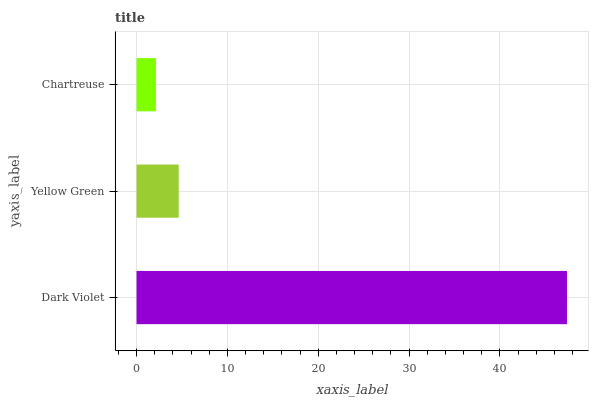Is Chartreuse the minimum?
Answer yes or no. Yes. Is Dark Violet the maximum?
Answer yes or no. Yes. Is Yellow Green the minimum?
Answer yes or no. No. Is Yellow Green the maximum?
Answer yes or no. No. Is Dark Violet greater than Yellow Green?
Answer yes or no. Yes. Is Yellow Green less than Dark Violet?
Answer yes or no. Yes. Is Yellow Green greater than Dark Violet?
Answer yes or no. No. Is Dark Violet less than Yellow Green?
Answer yes or no. No. Is Yellow Green the high median?
Answer yes or no. Yes. Is Yellow Green the low median?
Answer yes or no. Yes. Is Chartreuse the high median?
Answer yes or no. No. Is Dark Violet the low median?
Answer yes or no. No. 